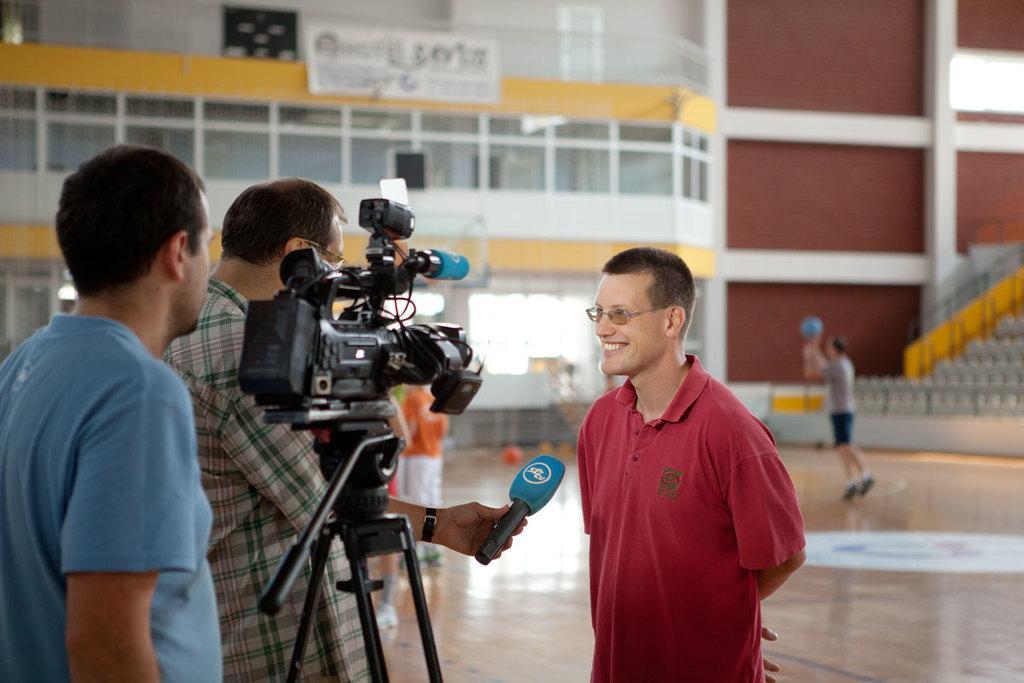Could you give a brief overview of what you see in this image? In this picture we can see a person standing in front of a mike and looking at someone. On the right side, we can see 2 people standing with a video recorder. 